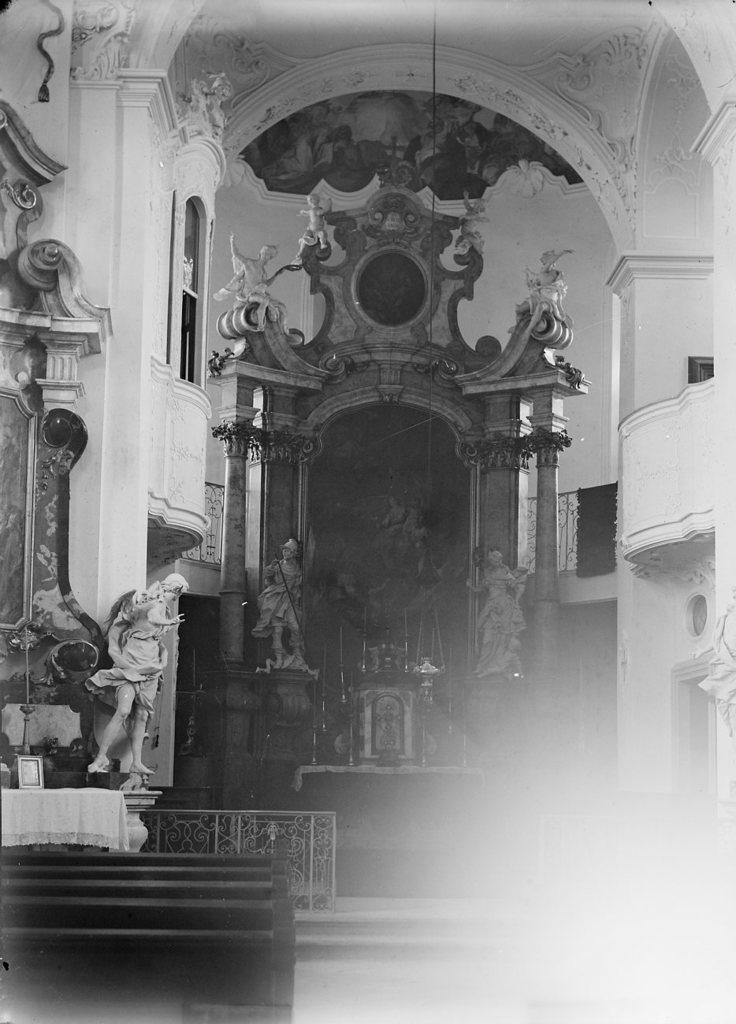Where was the image taken? The image was taken in a hall. What type of artwork can be seen in the image? There are sculptures in the image. What piece of furniture is present in the image? There is a table in the image. What architectural feature is visible in the image? There is a window in the image. What safety feature is present in the image? There are railings in the image. How much salt is on the table in the image? There is no salt present on the table in the image. What type of pot is visible in the image? There is no pot visible in the image. 